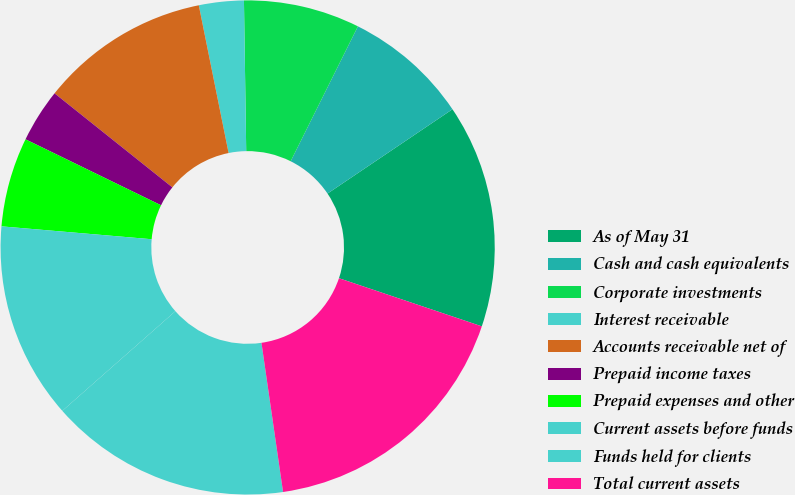Convert chart. <chart><loc_0><loc_0><loc_500><loc_500><pie_chart><fcel>As of May 31<fcel>Cash and cash equivalents<fcel>Corporate investments<fcel>Interest receivable<fcel>Accounts receivable net of<fcel>Prepaid income taxes<fcel>Prepaid expenses and other<fcel>Current assets before funds<fcel>Funds held for clients<fcel>Total current assets<nl><fcel>14.62%<fcel>8.19%<fcel>7.6%<fcel>2.93%<fcel>11.11%<fcel>3.51%<fcel>5.85%<fcel>12.86%<fcel>15.79%<fcel>17.54%<nl></chart> 